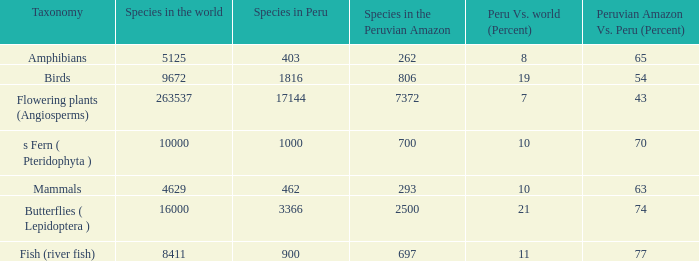What's the maximum peru vs. world (percent) with 9672 species in the world  19.0. 